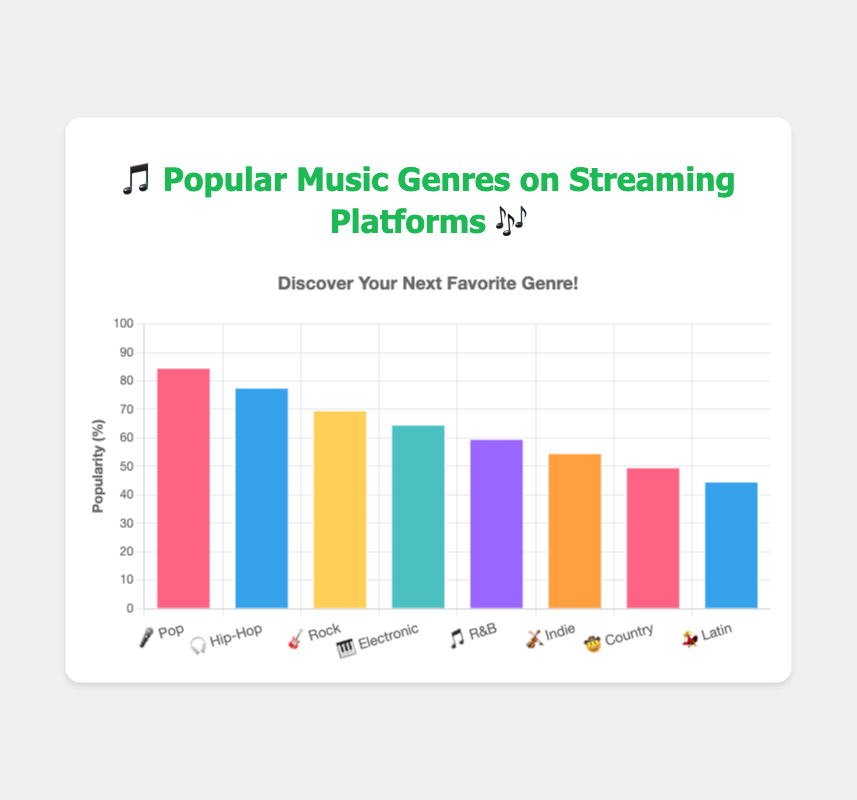Which genre has the highest popularity? The genre with the highest popularity can be seen by identifying the tallest bar. The tallest bar corresponds to Pop with a popularity of 85%.
Answer: Pop What is the popularity of the Country genre? Find the bar label for the Country genre (🤠 Country) and look at the height of the bar or the numerical value at the top, which is 50%.
Answer: 50% How many genres have a popularity above 60%? Count the number of bars with a value greater than 60%. Pop (85%), Hip-Hop (78%), and Rock (70%) all have values above 60%.
Answer: 3 Which genre is more popular, R&B or Indie? Compare the heights/bar values of R&B (🎵 R&B) and Indie (🎻 Indie). R&B has a popularity of 60%, while Indie has a popularity of 55%. Therefore, R&B is more popular.
Answer: R&B By how many percentage points is Pop more popular than Rock? Subtract the popularity of Rock (70%) from the popularity of Pop (85%). 85% - 70% = 15%.
Answer: 15 percentage points What is the combined popularity of Hip-Hop and Electronic genres? Add the popularity values of Hip-Hop (78%) and Electronic (65%). 78% + 65% = 143%.
Answer: 143% Which genre is the least popular? The shortest bar represents the least popular genre. The shortest bar corresponds to Latin (💃 Latin) with a popularity of 45%.
Answer: Latin Across all genres, what is the average popularity? Sum the popularity values: 85% + 78% + 70% + 65% + 60% + 55% + 50% + 45% = 508%. Divide by the number of genres (8). 508% / 8 = 63.5%.
Answer: 63.5% Is there any genre with an exactly equal popularity to its emoji representation's number of characters? For instance, "🎵" is one character, so we look for a popularity exactly equal to 1%. Count the characters within each emoji representation and match it to its popularity. None of the genres' popularity values match the number of characters in their emoji representations.
Answer: No 